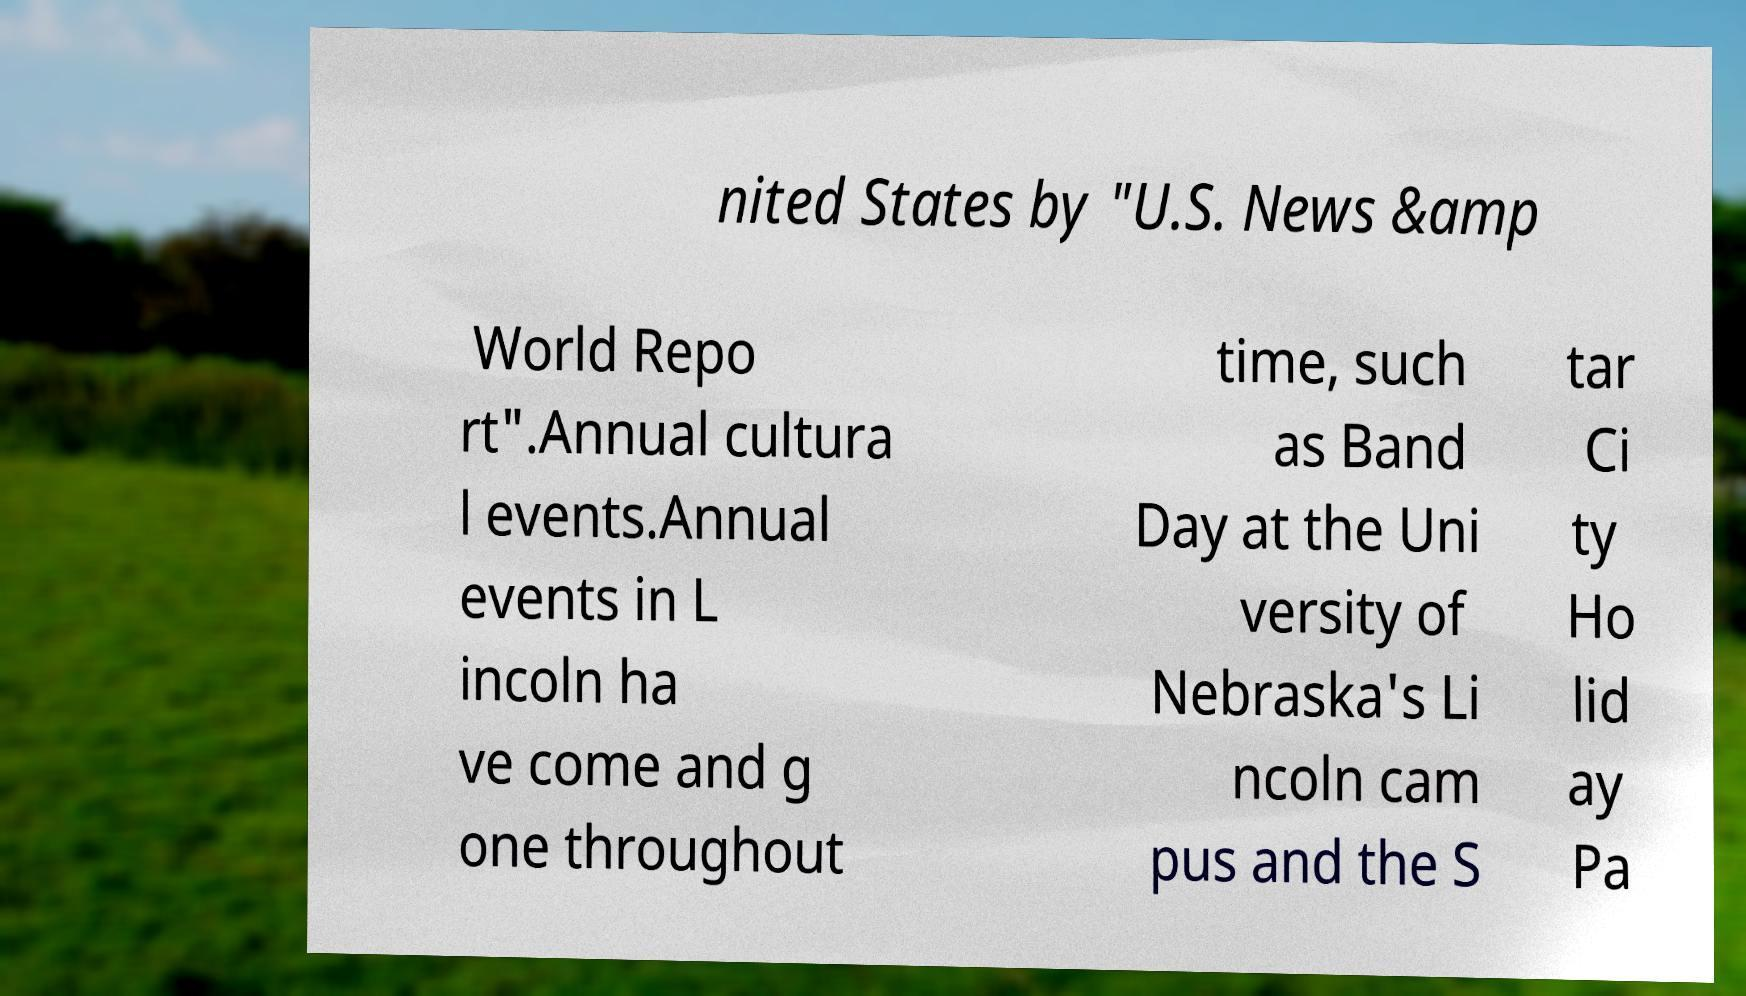What messages or text are displayed in this image? I need them in a readable, typed format. nited States by "U.S. News &amp World Repo rt".Annual cultura l events.Annual events in L incoln ha ve come and g one throughout time, such as Band Day at the Uni versity of Nebraska's Li ncoln cam pus and the S tar Ci ty Ho lid ay Pa 